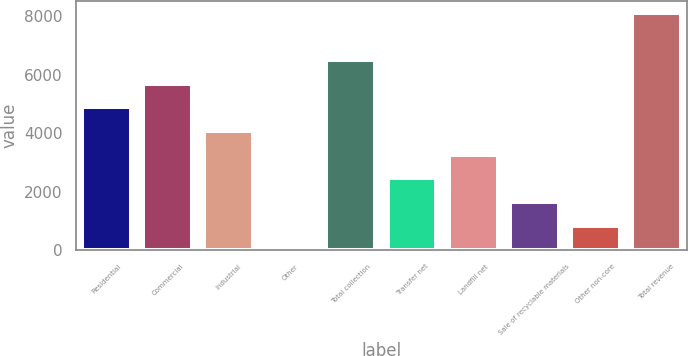<chart> <loc_0><loc_0><loc_500><loc_500><bar_chart><fcel>Residential<fcel>Commercial<fcel>Industrial<fcel>Other<fcel>Total collection<fcel>Transfer net<fcel>Landfill net<fcel>Sale of recyclable materials<fcel>Other non-core<fcel>Total revenue<nl><fcel>4884.34<fcel>5692.83<fcel>4075.85<fcel>33.4<fcel>6501.32<fcel>2458.87<fcel>3267.36<fcel>1650.38<fcel>841.89<fcel>8118.3<nl></chart> 